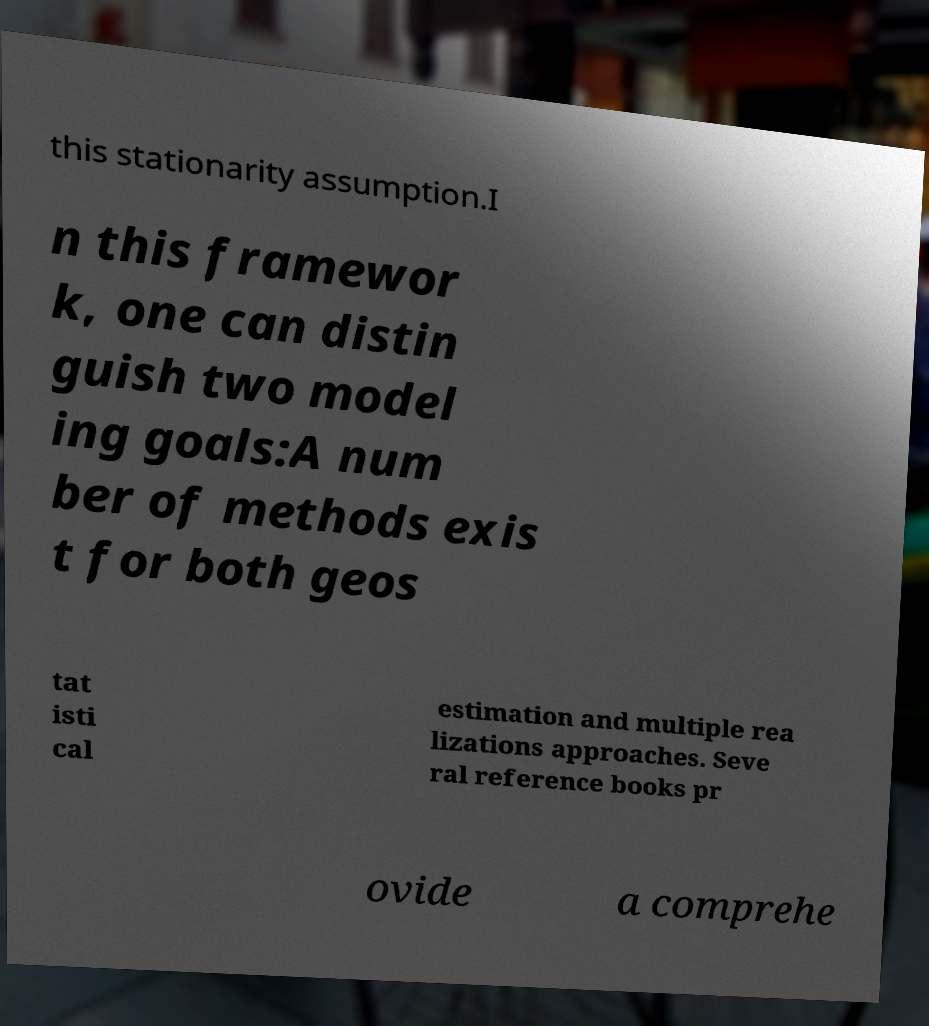Please read and relay the text visible in this image. What does it say? this stationarity assumption.I n this framewor k, one can distin guish two model ing goals:A num ber of methods exis t for both geos tat isti cal estimation and multiple rea lizations approaches. Seve ral reference books pr ovide a comprehe 